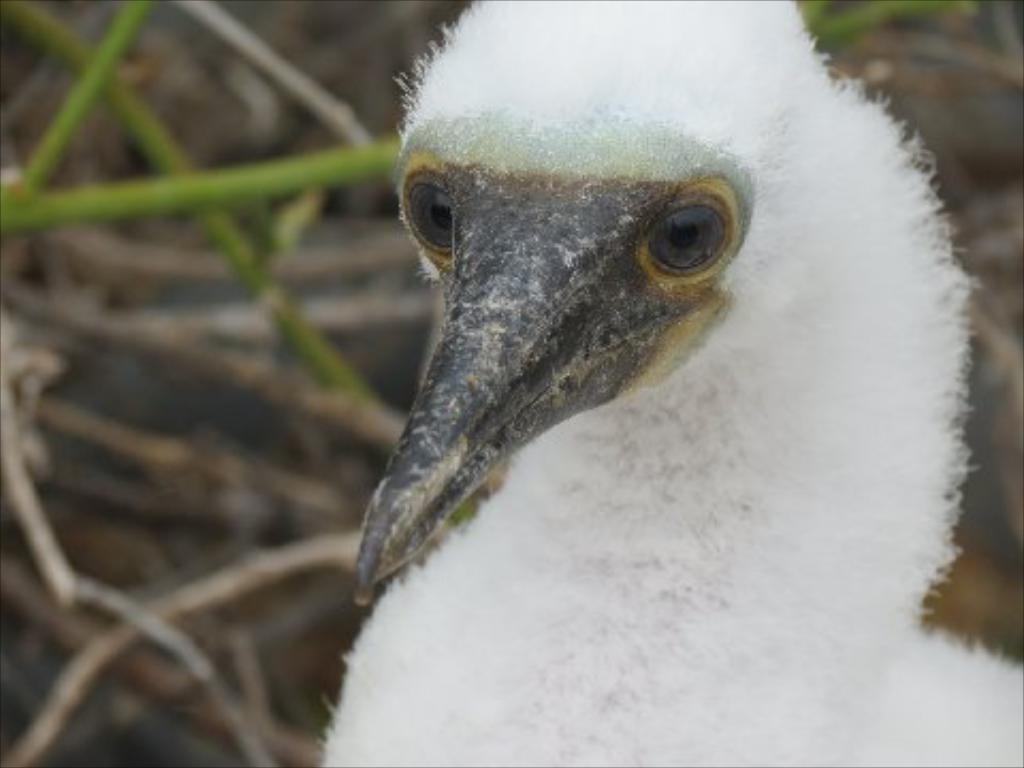Describe this image in one or two sentences. In this image, we can see a bird and in the background, there are twigs. 